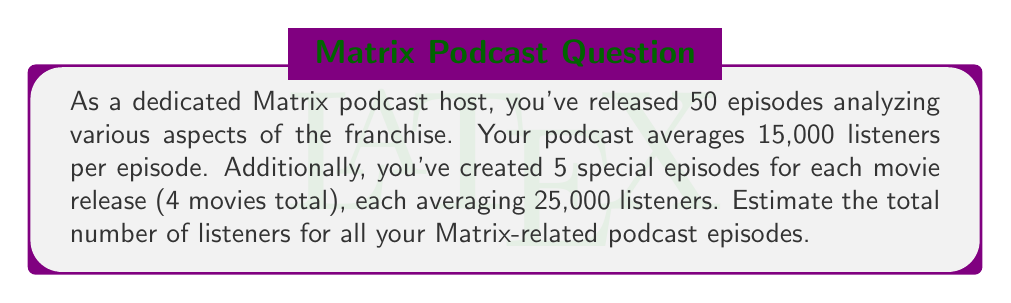Could you help me with this problem? To solve this problem, we'll break it down into steps:

1. Calculate the total listeners for regular episodes:
   $$ 50 \text{ episodes} \times 15,000 \text{ listeners} = 750,000 \text{ listeners} $$

2. Calculate the total listeners for special episodes:
   $$ 5 \text{ specials} \times 4 \text{ movies} \times 25,000 \text{ listeners} = 500,000 \text{ listeners} $$

3. Sum up the total listeners:
   $$ 750,000 + 500,000 = 1,250,000 \text{ listeners} $$

This calculation gives us the exact number, but since the question asks for an estimate, we can round it to 1.25 million listeners.
Answer: Approximately 1.25 million listeners 